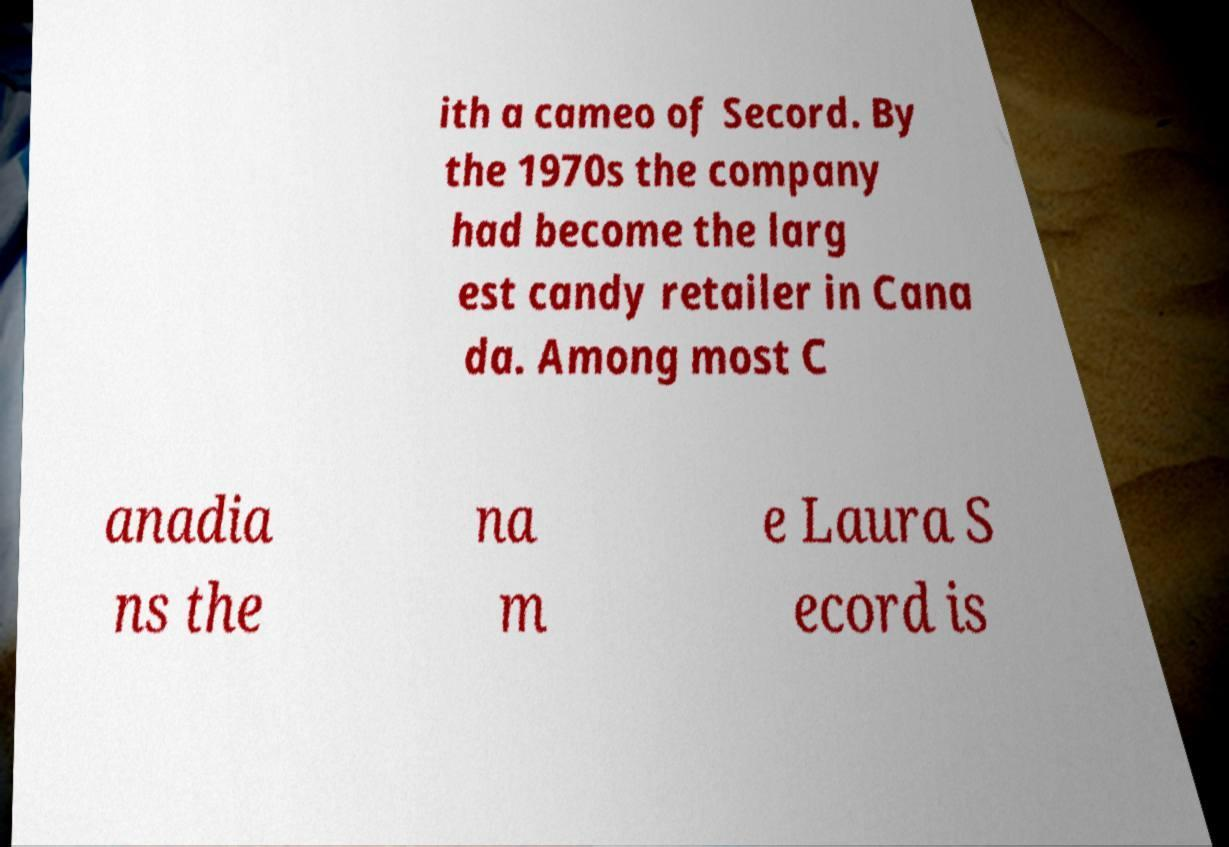Please read and relay the text visible in this image. What does it say? ith a cameo of Secord. By the 1970s the company had become the larg est candy retailer in Cana da. Among most C anadia ns the na m e Laura S ecord is 